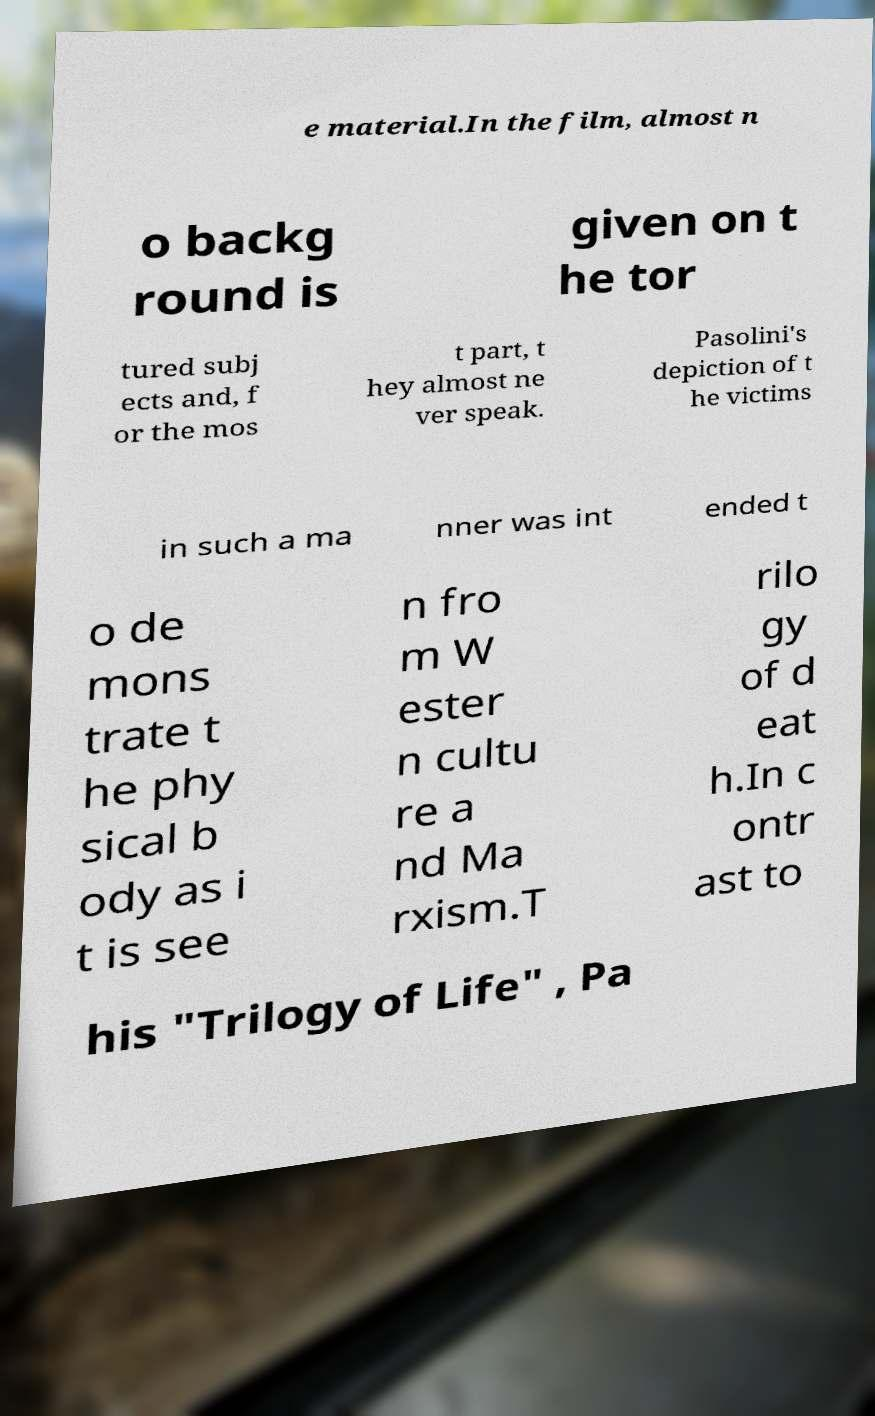Can you read and provide the text displayed in the image?This photo seems to have some interesting text. Can you extract and type it out for me? e material.In the film, almost n o backg round is given on t he tor tured subj ects and, f or the mos t part, t hey almost ne ver speak. Pasolini's depiction of t he victims in such a ma nner was int ended t o de mons trate t he phy sical b ody as i t is see n fro m W ester n cultu re a nd Ma rxism.T rilo gy of d eat h.In c ontr ast to his "Trilogy of Life" , Pa 